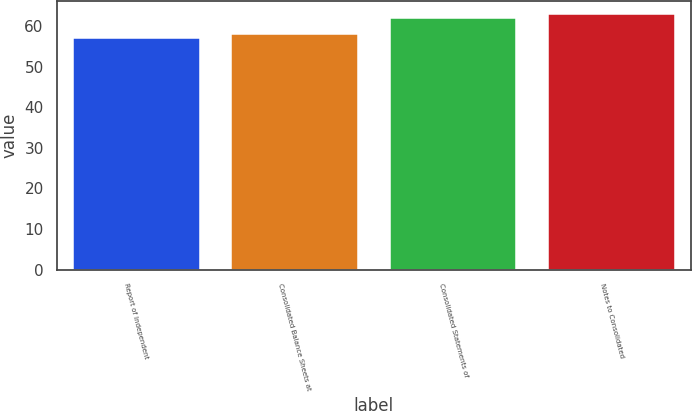Convert chart. <chart><loc_0><loc_0><loc_500><loc_500><bar_chart><fcel>Report of Independent<fcel>Consolidated Balance Sheets at<fcel>Consolidated Statements of<fcel>Notes to Consolidated<nl><fcel>57<fcel>58<fcel>62<fcel>63<nl></chart> 